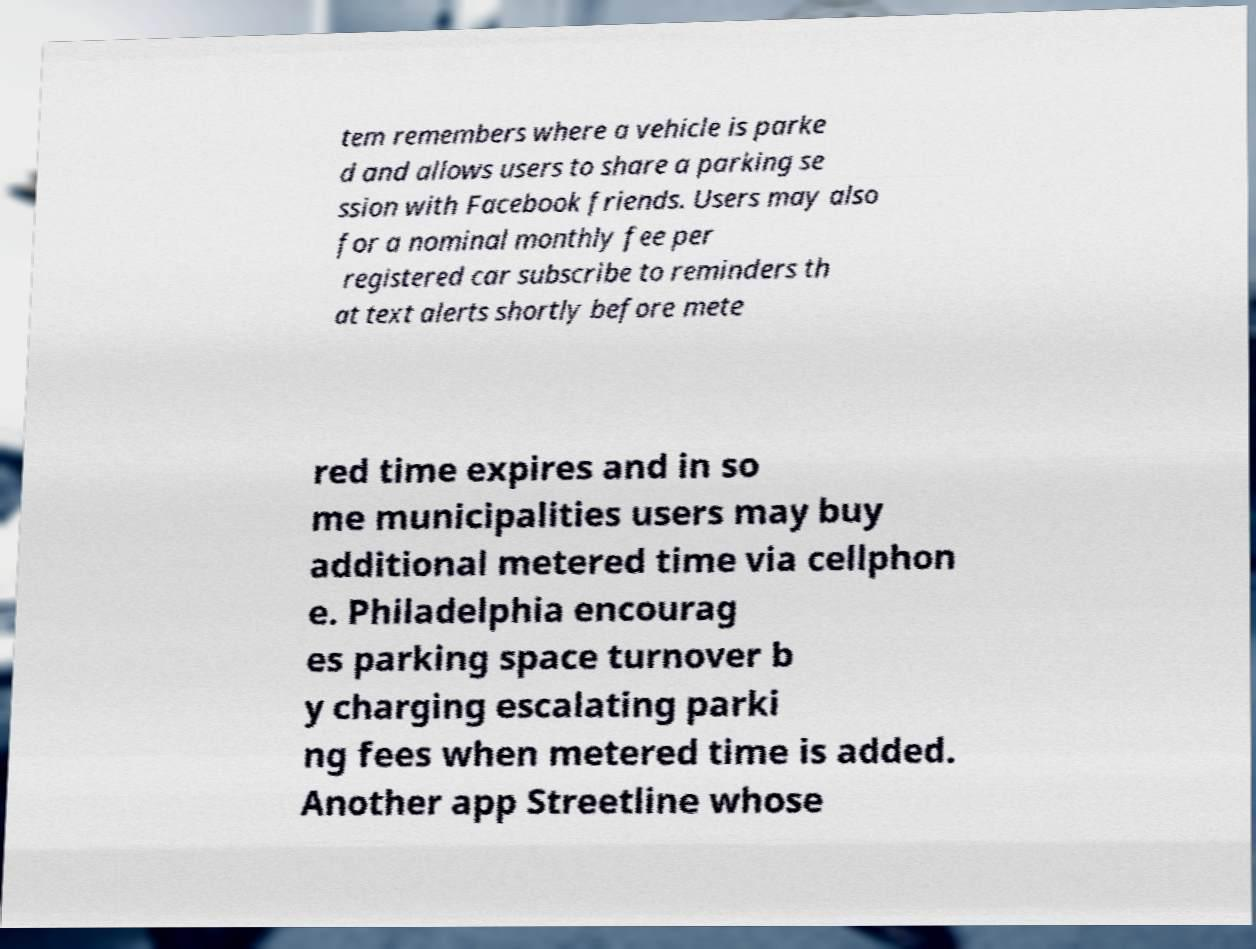What messages or text are displayed in this image? I need them in a readable, typed format. tem remembers where a vehicle is parke d and allows users to share a parking se ssion with Facebook friends. Users may also for a nominal monthly fee per registered car subscribe to reminders th at text alerts shortly before mete red time expires and in so me municipalities users may buy additional metered time via cellphon e. Philadelphia encourag es parking space turnover b y charging escalating parki ng fees when metered time is added. Another app Streetline whose 